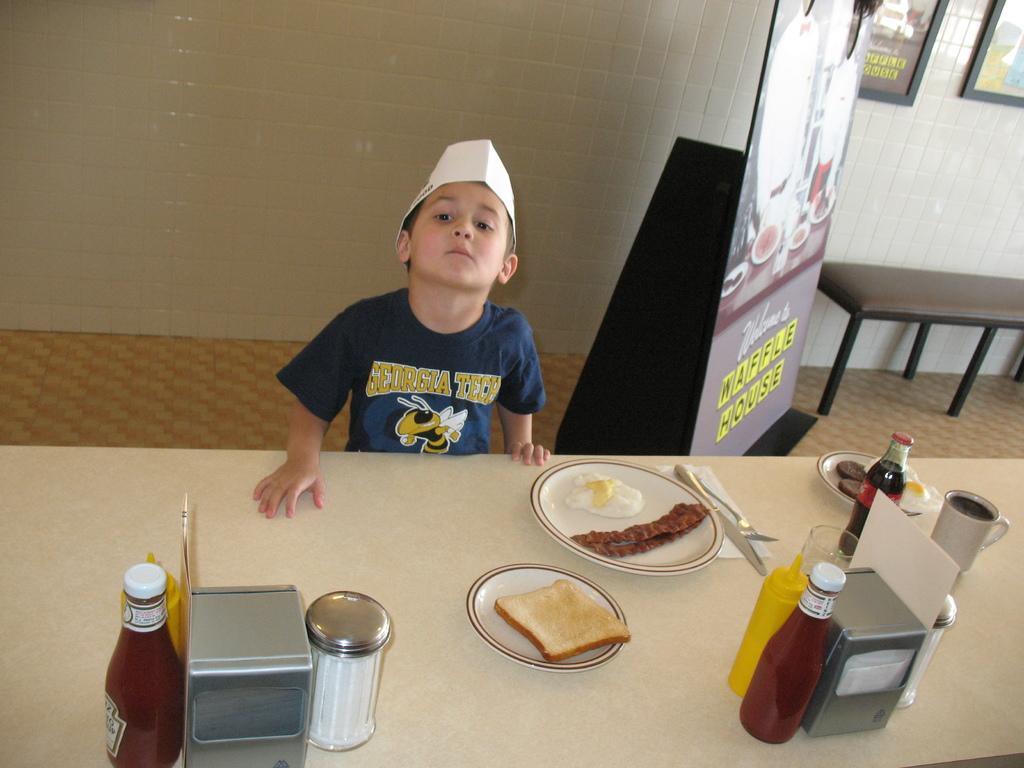Could you give a brief overview of what you see in this image? This is the picture of a little guy who is standing in front of the table on which there are two plates, cups, jars and some things placed on it and there is a table and two frames to the wall. 